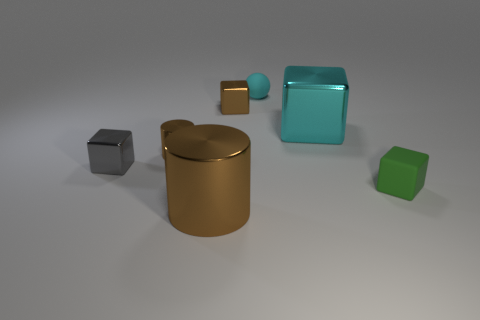Add 1 brown matte spheres. How many objects exist? 8 Subtract all cubes. How many objects are left? 3 Subtract 0 cyan cylinders. How many objects are left? 7 Subtract all gray metallic objects. Subtract all cyan cubes. How many objects are left? 5 Add 4 cyan rubber balls. How many cyan rubber balls are left? 5 Add 3 small green shiny cylinders. How many small green shiny cylinders exist? 3 